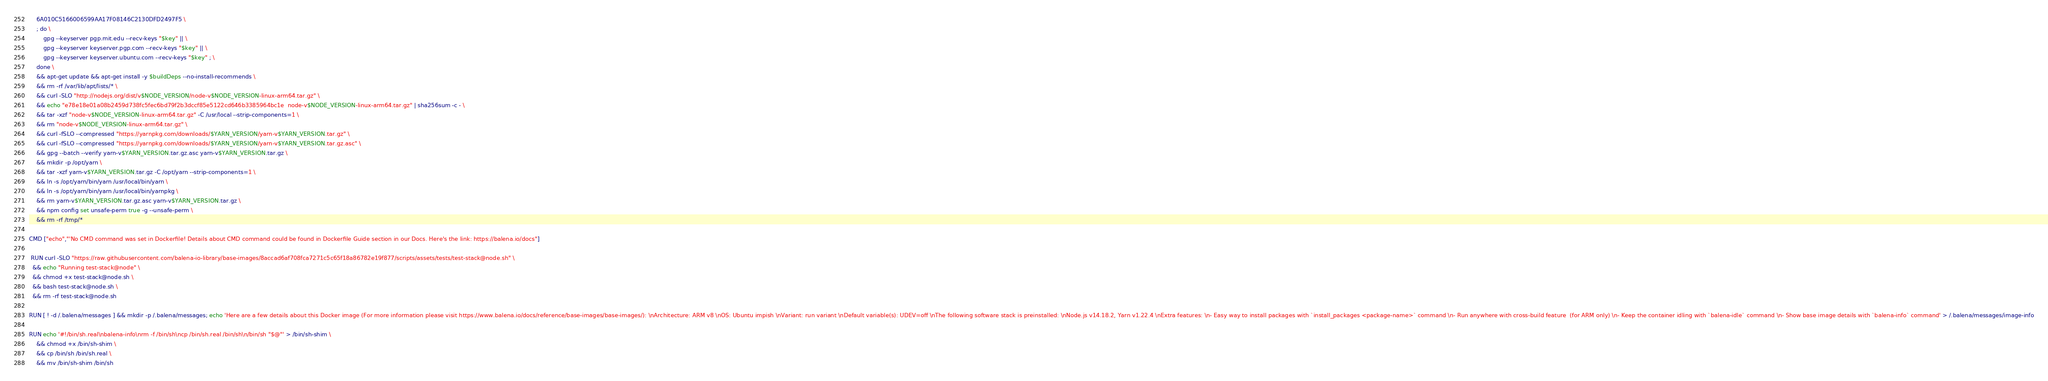Convert code to text. <code><loc_0><loc_0><loc_500><loc_500><_Dockerfile_>	6A010C5166006599AA17F08146C2130DFD2497F5 \
	; do \
		gpg --keyserver pgp.mit.edu --recv-keys "$key" || \
		gpg --keyserver keyserver.pgp.com --recv-keys "$key" || \
		gpg --keyserver keyserver.ubuntu.com --recv-keys "$key" ; \
	done \
	&& apt-get update && apt-get install -y $buildDeps --no-install-recommends \
	&& rm -rf /var/lib/apt/lists/* \
	&& curl -SLO "http://nodejs.org/dist/v$NODE_VERSION/node-v$NODE_VERSION-linux-arm64.tar.gz" \
	&& echo "e78e18e01a08b2459d738fc5fec6bd79f2b3dccf85e5122cd646b3385964bc1e  node-v$NODE_VERSION-linux-arm64.tar.gz" | sha256sum -c - \
	&& tar -xzf "node-v$NODE_VERSION-linux-arm64.tar.gz" -C /usr/local --strip-components=1 \
	&& rm "node-v$NODE_VERSION-linux-arm64.tar.gz" \
	&& curl -fSLO --compressed "https://yarnpkg.com/downloads/$YARN_VERSION/yarn-v$YARN_VERSION.tar.gz" \
	&& curl -fSLO --compressed "https://yarnpkg.com/downloads/$YARN_VERSION/yarn-v$YARN_VERSION.tar.gz.asc" \
	&& gpg --batch --verify yarn-v$YARN_VERSION.tar.gz.asc yarn-v$YARN_VERSION.tar.gz \
	&& mkdir -p /opt/yarn \
	&& tar -xzf yarn-v$YARN_VERSION.tar.gz -C /opt/yarn --strip-components=1 \
	&& ln -s /opt/yarn/bin/yarn /usr/local/bin/yarn \
	&& ln -s /opt/yarn/bin/yarn /usr/local/bin/yarnpkg \
	&& rm yarn-v$YARN_VERSION.tar.gz.asc yarn-v$YARN_VERSION.tar.gz \
	&& npm config set unsafe-perm true -g --unsafe-perm \
	&& rm -rf /tmp/*

CMD ["echo","'No CMD command was set in Dockerfile! Details about CMD command could be found in Dockerfile Guide section in our Docs. Here's the link: https://balena.io/docs"]

 RUN curl -SLO "https://raw.githubusercontent.com/balena-io-library/base-images/8accad6af708fca7271c5c65f18a86782e19f877/scripts/assets/tests/test-stack@node.sh" \
  && echo "Running test-stack@node" \
  && chmod +x test-stack@node.sh \
  && bash test-stack@node.sh \
  && rm -rf test-stack@node.sh 

RUN [ ! -d /.balena/messages ] && mkdir -p /.balena/messages; echo 'Here are a few details about this Docker image (For more information please visit https://www.balena.io/docs/reference/base-images/base-images/): \nArchitecture: ARM v8 \nOS: Ubuntu impish \nVariant: run variant \nDefault variable(s): UDEV=off \nThe following software stack is preinstalled: \nNode.js v14.18.2, Yarn v1.22.4 \nExtra features: \n- Easy way to install packages with `install_packages <package-name>` command \n- Run anywhere with cross-build feature  (for ARM only) \n- Keep the container idling with `balena-idle` command \n- Show base image details with `balena-info` command' > /.balena/messages/image-info

RUN echo '#!/bin/sh.real\nbalena-info\nrm -f /bin/sh\ncp /bin/sh.real /bin/sh\n/bin/sh "$@"' > /bin/sh-shim \
	&& chmod +x /bin/sh-shim \
	&& cp /bin/sh /bin/sh.real \
	&& mv /bin/sh-shim /bin/sh</code> 